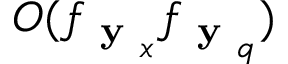<formula> <loc_0><loc_0><loc_500><loc_500>O ( f _ { y _ { x } } f _ { y _ { q } } )</formula> 